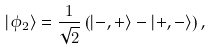<formula> <loc_0><loc_0><loc_500><loc_500>| \phi _ { 2 } \rangle = \frac { 1 } { \sqrt { 2 } } \left ( | - , + \rangle - | + , - \rangle \right ) ,</formula> 